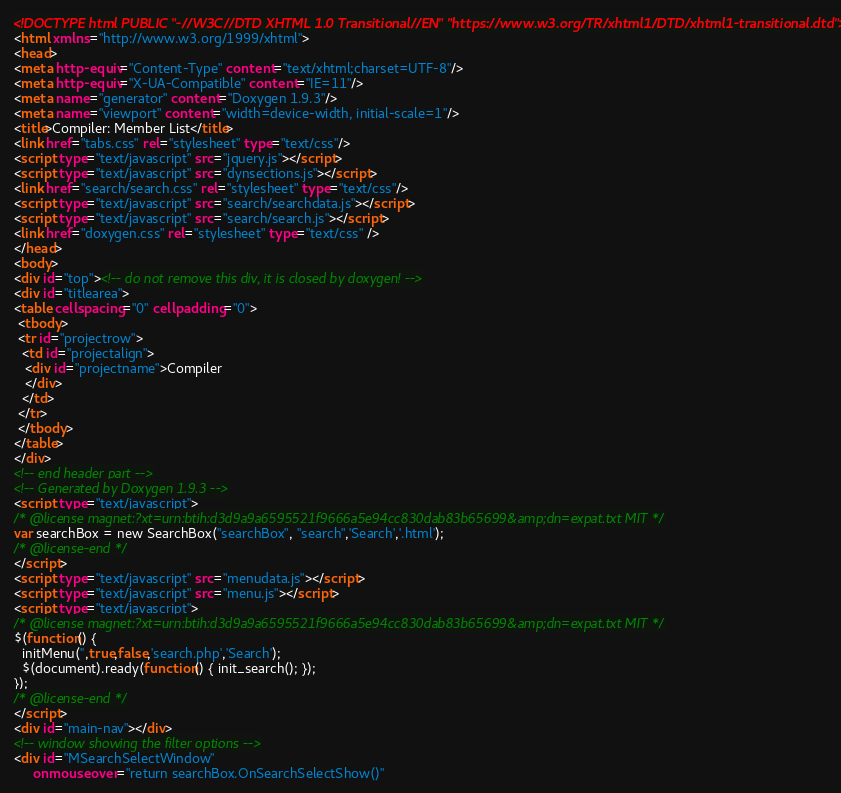Convert code to text. <code><loc_0><loc_0><loc_500><loc_500><_HTML_><!DOCTYPE html PUBLIC "-//W3C//DTD XHTML 1.0 Transitional//EN" "https://www.w3.org/TR/xhtml1/DTD/xhtml1-transitional.dtd">
<html xmlns="http://www.w3.org/1999/xhtml">
<head>
<meta http-equiv="Content-Type" content="text/xhtml;charset=UTF-8"/>
<meta http-equiv="X-UA-Compatible" content="IE=11"/>
<meta name="generator" content="Doxygen 1.9.3"/>
<meta name="viewport" content="width=device-width, initial-scale=1"/>
<title>Compiler: Member List</title>
<link href="tabs.css" rel="stylesheet" type="text/css"/>
<script type="text/javascript" src="jquery.js"></script>
<script type="text/javascript" src="dynsections.js"></script>
<link href="search/search.css" rel="stylesheet" type="text/css"/>
<script type="text/javascript" src="search/searchdata.js"></script>
<script type="text/javascript" src="search/search.js"></script>
<link href="doxygen.css" rel="stylesheet" type="text/css" />
</head>
<body>
<div id="top"><!-- do not remove this div, it is closed by doxygen! -->
<div id="titlearea">
<table cellspacing="0" cellpadding="0">
 <tbody>
 <tr id="projectrow">
  <td id="projectalign">
   <div id="projectname">Compiler
   </div>
  </td>
 </tr>
 </tbody>
</table>
</div>
<!-- end header part -->
<!-- Generated by Doxygen 1.9.3 -->
<script type="text/javascript">
/* @license magnet:?xt=urn:btih:d3d9a9a6595521f9666a5e94cc830dab83b65699&amp;dn=expat.txt MIT */
var searchBox = new SearchBox("searchBox", "search",'Search','.html');
/* @license-end */
</script>
<script type="text/javascript" src="menudata.js"></script>
<script type="text/javascript" src="menu.js"></script>
<script type="text/javascript">
/* @license magnet:?xt=urn:btih:d3d9a9a6595521f9666a5e94cc830dab83b65699&amp;dn=expat.txt MIT */
$(function() {
  initMenu('',true,false,'search.php','Search');
  $(document).ready(function() { init_search(); });
});
/* @license-end */
</script>
<div id="main-nav"></div>
<!-- window showing the filter options -->
<div id="MSearchSelectWindow"
     onmouseover="return searchBox.OnSearchSelectShow()"</code> 